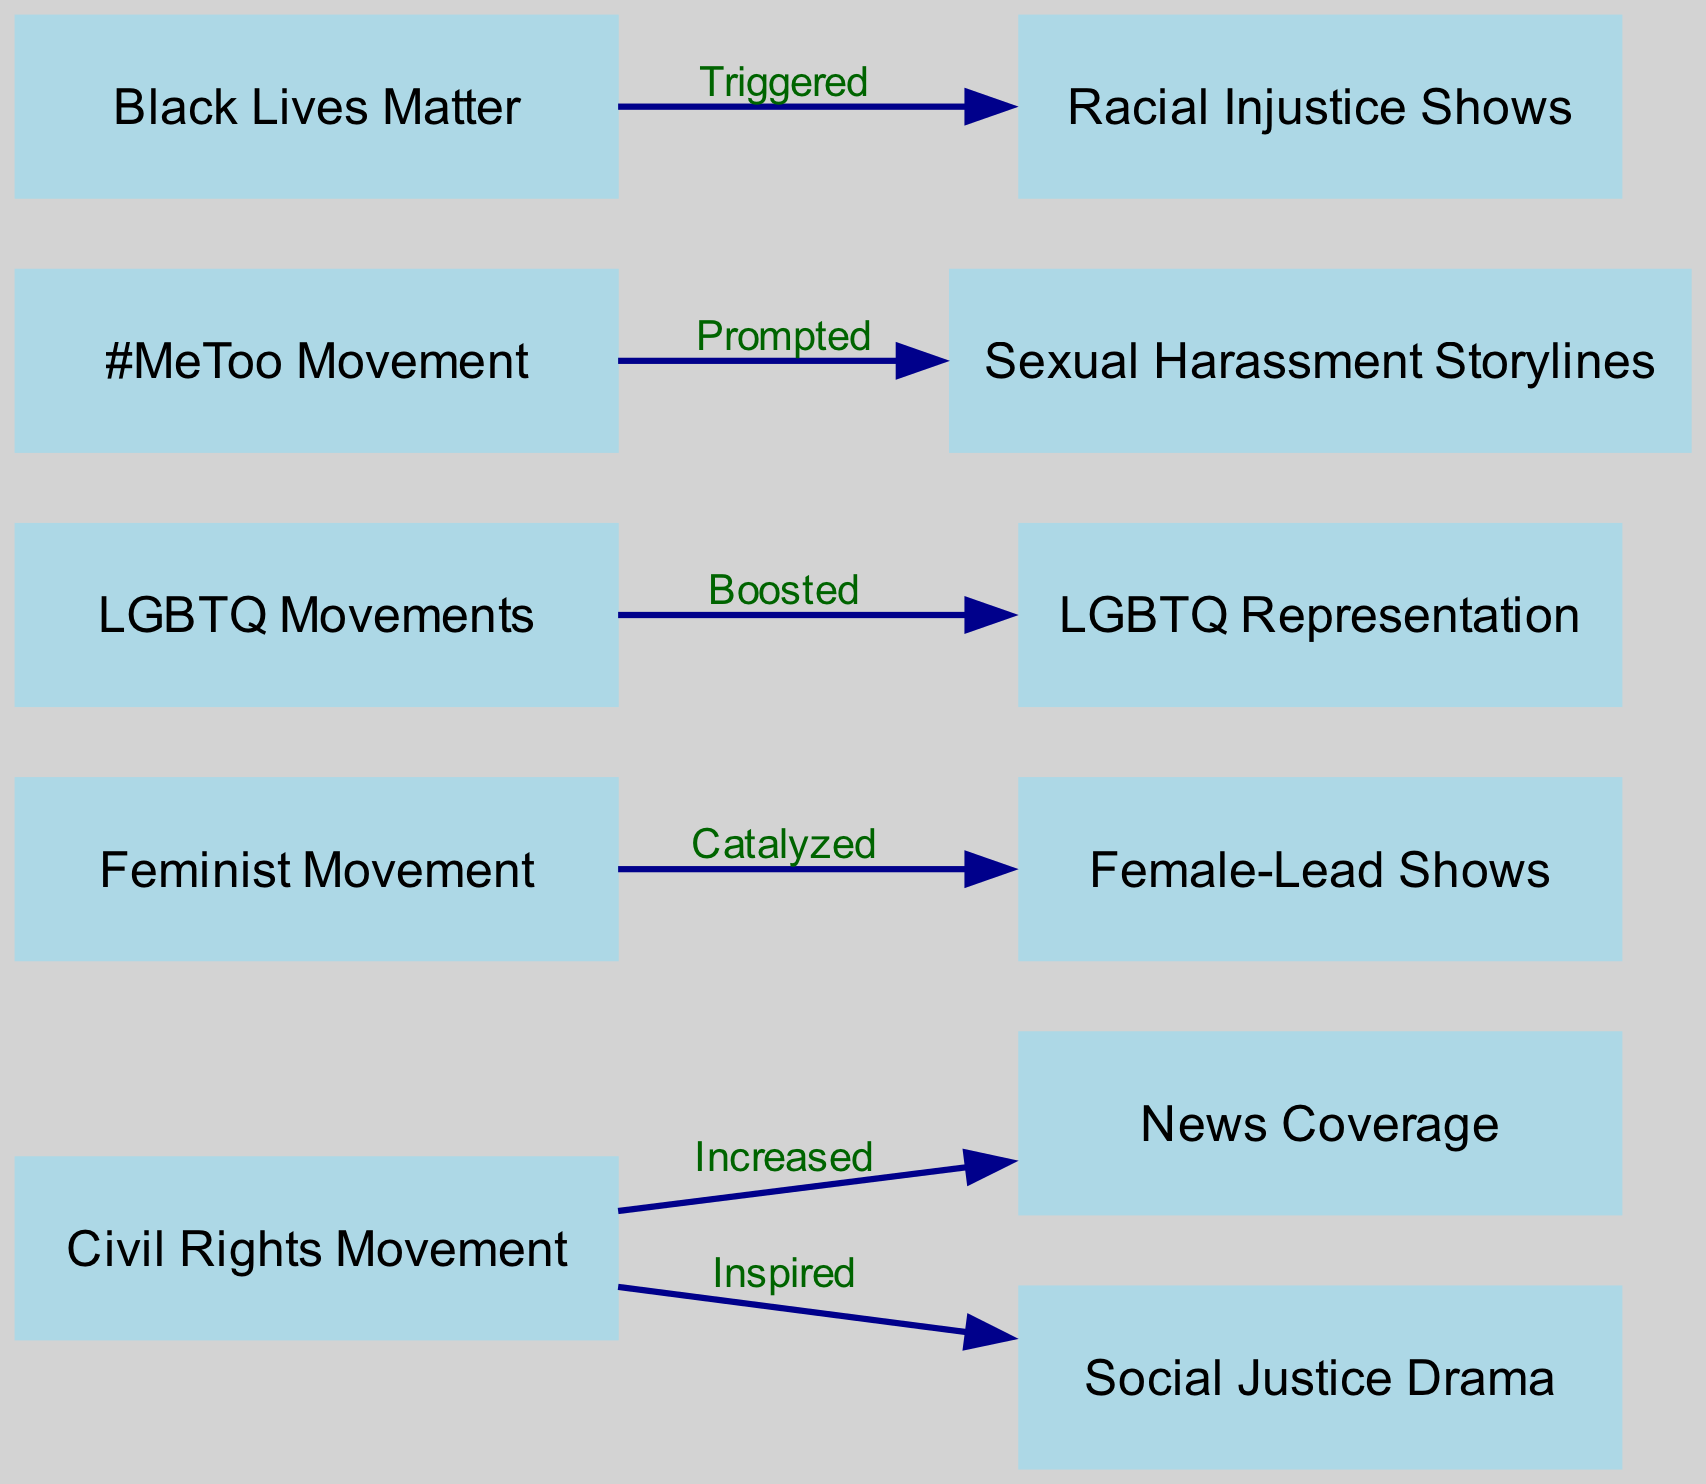What movement inspired social justice drama? The diagram shows an edge from the Civil Rights Movement to Social Justice Drama labeled "Inspired." This indicates that the Civil Rights Movement was the source of inspiration for the development of social justice dramas on television.
Answer: Civil Rights Movement How many nodes are present in the diagram? The diagram lists a total of 11 nodes, which are various movements and television programming related to those movements. This can be counted directly from the visual representation.
Answer: 11 What term describes the influence of the Feminist Movement on television shows? The diagram shows a directed edge from the Feminist Movement to Female-Lead Shows, labeled "Catalyzed." This indicates that the Feminist Movement played a significant role in the creation or increase of female-led television shows.
Answer: Catalyzed Which movement boosted LGBTQ representation? The diagram indicates that LGBTQ Movements had a positive effect on LGBTQ Representation, as shown by the labeled edge "Boosted." This clearly identifies the relationship between the two nodes.
Answer: LGBTQ Movements What type of storylines were prompted by the #MeToo Movement? According to the diagram, there is an edge labeled "Prompted" that connects the #MeToo Movement to Sexual Harassment Storylines, illustrating that the movement led to the inclusion of such storylines in television.
Answer: Sexual Harassment Storylines Which social movement triggered racial injustice shows? The diagram connects the Black Lives Matter movements to Racial Injustice Shows with the label "Triggered," demonstrating the direct influence of this movement on the content regarding racial injustice.
Answer: Black Lives Matter How many edges are there in total on the diagram? By examining the diagram, we can count a total of 6 edges that represent the relationships between the various movements and television programming. This is confirmed by counting each connection visually.
Answer: 6 Which node does news coverage connect to in the diagram? The Civil Rights Movement connects to News Coverage, as indicated by an edge labeled "Increased." This signifies the relationship where the movement influenced the portrayal of related news coverage on television.
Answer: News Coverage What is a notable effect of LGBTQ Movements on television content? The influence indicated in the diagram shows that LGBTQ Movements led to an increase in LGBTQ Representation, as suggested by the edge labeled "Boosted." This represents the notable effect of these movements within the TV landscape.
Answer: LGBTQ Representation 